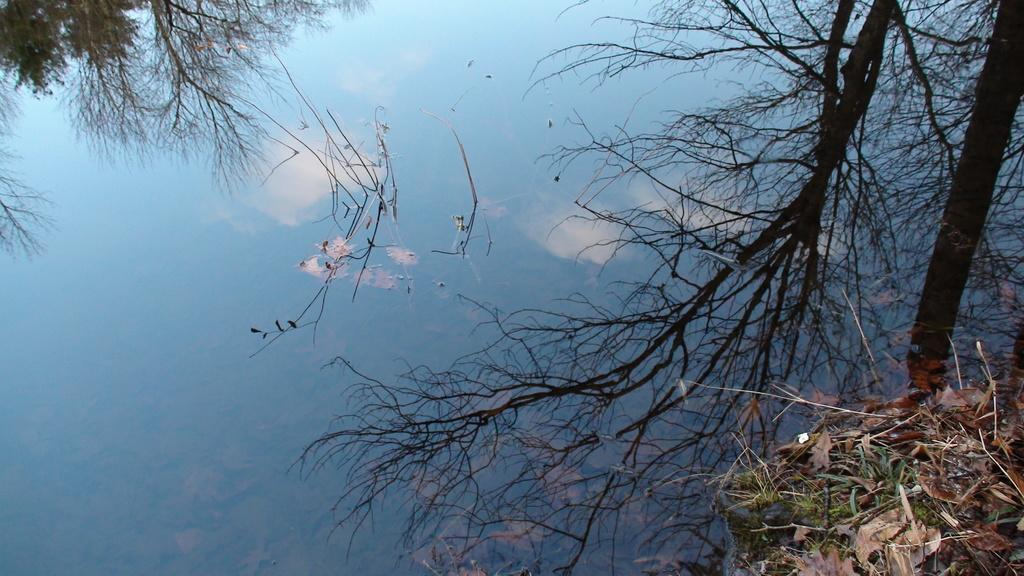What is the primary element in the image? There is water in the image. What can be observed on the surface of the water? There are shadows of trees on the water. What is present in the bottom right corner of the image? There are leaves in the bottom right corner of the image. Can you see a family playing with a balloon in the image? There is no family or balloon present in the image. Is there a baseball game happening in the image? There is no baseball game or any reference to sports in the image. 